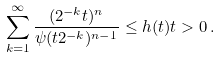Convert formula to latex. <formula><loc_0><loc_0><loc_500><loc_500>\sum _ { k = 1 } ^ { \infty } \frac { ( 2 ^ { - k } t ) ^ { n } } { \psi ( t 2 ^ { - k } ) ^ { n - 1 } } \leq h ( t ) t > 0 \, .</formula> 